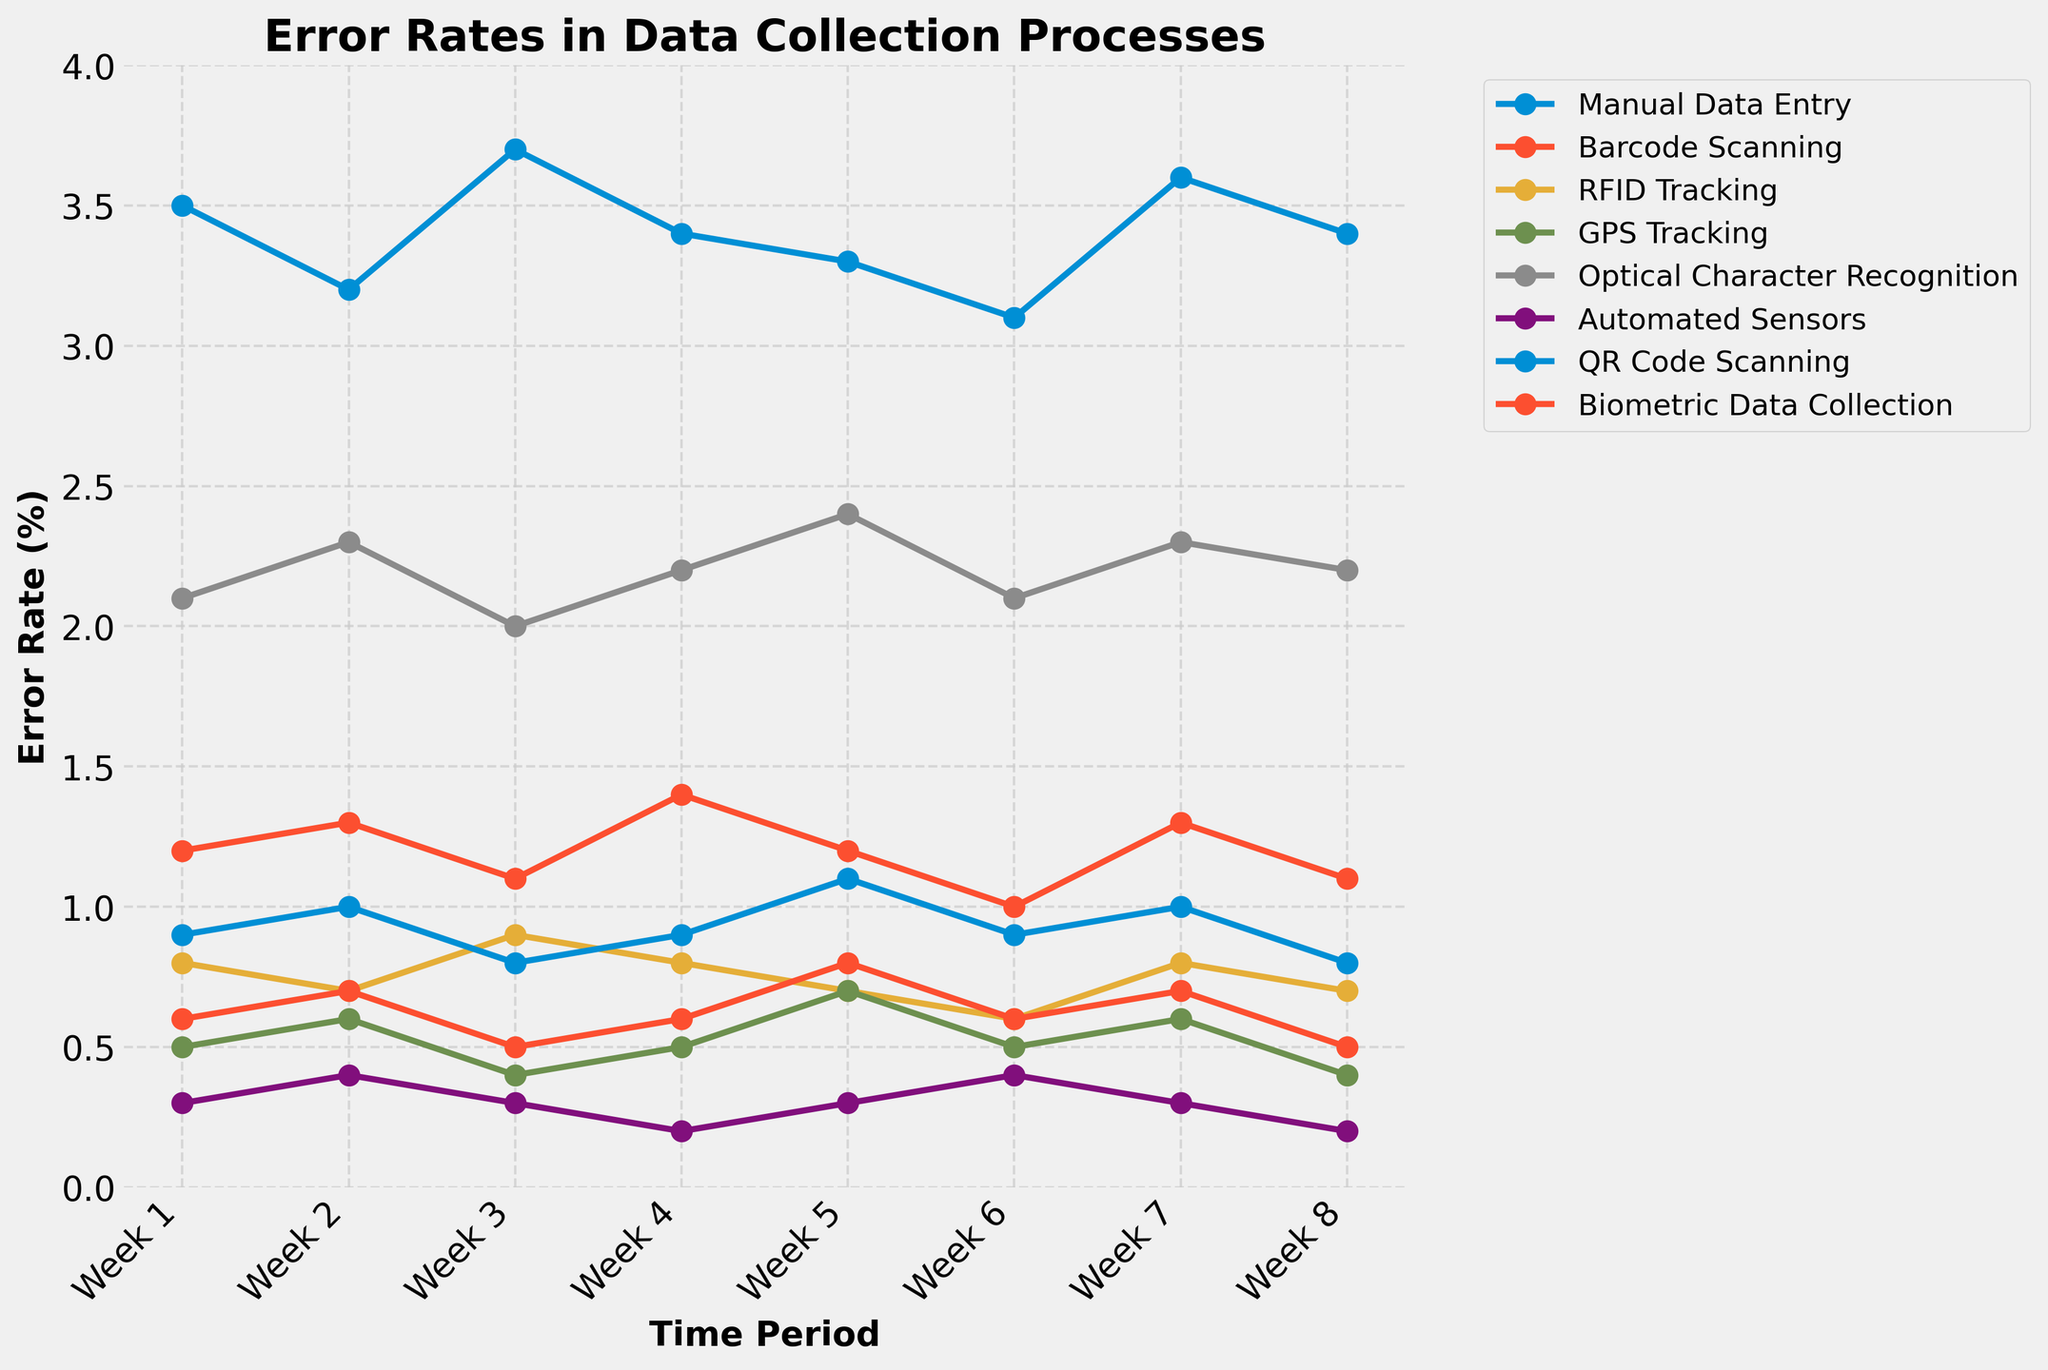What tracking method has the highest error rate in Week 1? By looking at the lines on the chart, the Manual Data Entry method starts off with the highest point in Week 1.
Answer: Manual Data Entry Which tracking method has the lowest error rate across all weeks? The line for Automated Sensors consistently remains at the lowest level compared to other methods in each week.
Answer: Automated Sensors Did any tracking method show a steady decrease in error rate over the weeks? By inspecting the chart, we can see that RFID Tracking shows a generally steady decrease with slight fluctuations, but with an overall downward trend.
Answer: RFID Tracking Which two tracking methods have error rates that never exceed 1% in any week? By looking at the plotted lines and their labels, both Automated Sensors and GPS Tracking have error rates consistently below 1% across all weeks.
Answer: Automated Sensors, GPS Tracking What is the combined error rate for QR Code Scanning and Barcode Scanning in Week 4? QR Code Scanning has an error rate of 0.9% and Barcode Scanning has 1.4% in Week 4. Therefore, the combined error rate is 0.9 + 1.4 = 2.3%.
Answer: 2.3% Which tracking method has the highest overall variability in error rates over the weeks? The variability can be observed by the steepness and frequency of changes in the lines. Manual Data Entry shows the most fluctuations, with error rates ranging from 3.1% to 3.7%.
Answer: Manual Data Entry How does the error rate of Biometric Data Collection in Week 2 compare to RFID Tracking in Week 4? Biometric Data Collection has an error rate of 0.7% in Week 2, while RFID Tracking has the same error rate of 0.8% in Week 4. Therefore, Biometric Data Collection in Week 2 is slightly lower.
Answer: Biometric Data Collection Week 2 is lower What is the average error rate for Optical Character Recognition across all weeks? Summing up the error rates for Optical Character Recognition over all weeks (2.1+2.3+2.0+2.2+2.4+2.1+2.3+2.2), we get 17.6. Dividing by 8 weeks, the average error rate is 17.6/8 = 2.2%.
Answer: 2.2% Which tracking method showed the most significant improvement in error rate from Week 1 to Week 8? Comparing the starting and ending points of each line, Automated Sensors show a remarkable decrease from 0.3% to 0.2%, but this is relatively small. RFID Tracking starts at 0.8% and ends at 0.7%, while GPS Tracking goes from 0.5% to 0.4%. The most noticeable improvement in percentage points is primarily seen in RFID Tracking.
Answer: RFID Tracking How do the error rates of Barcode Scanning and QR Code Scanning compare in Week 6? In Week 6, Barcode Scanning has an error rate of 1.0% and QR Code Scanning also has an error rate of 0.9%. Barcode Scanning is slightly higher.
Answer: Barcode Scanning is higher 